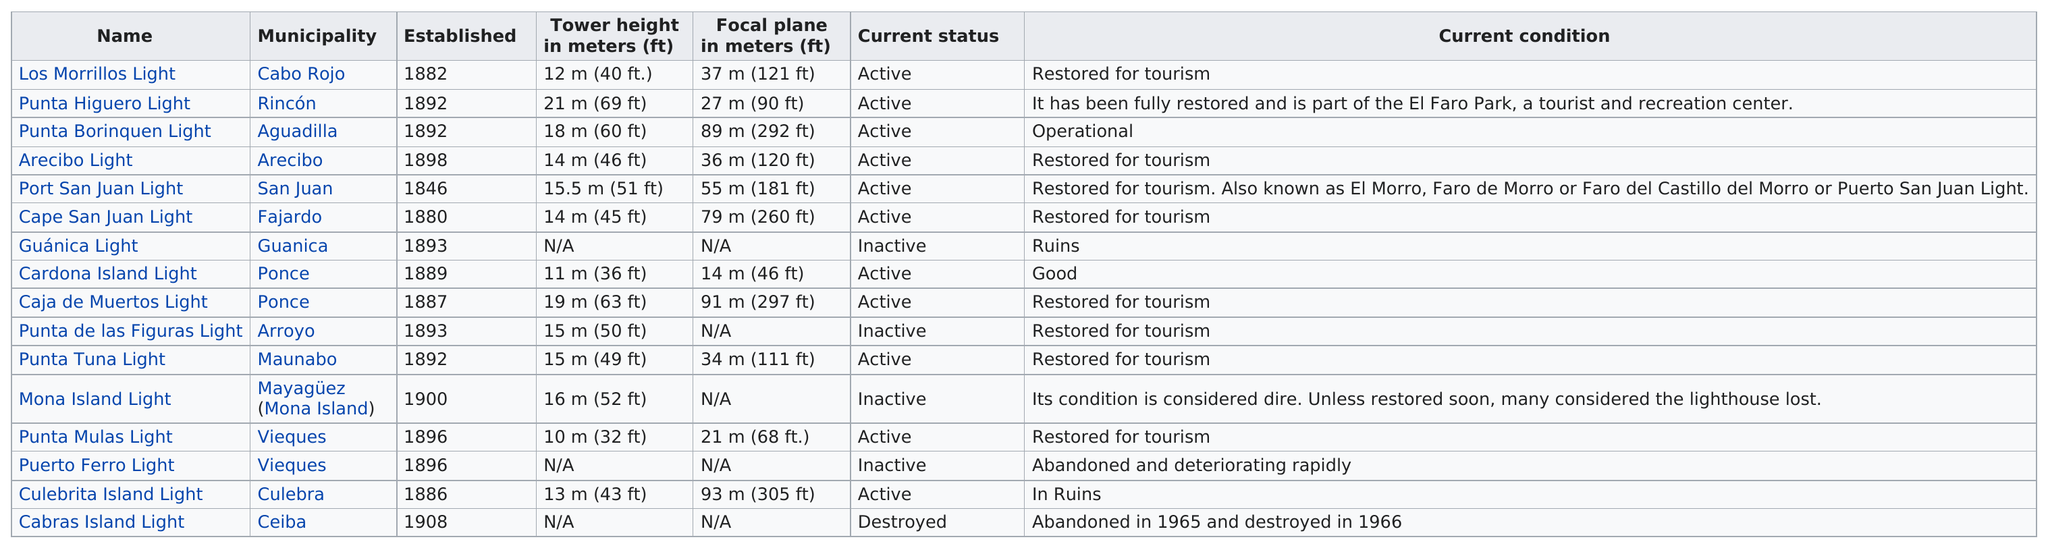Specify some key components in this picture. Cardona Island Light and Caja de Muertos Light are located within the jurisdiction of the municipality of Ponce. San Juan was the first municipality to be established. According to historical records, a total of 13 lighthouses were established prior to 1898. Prior to 1880, several municipalities were established, including San Juan. According to the information provided, it can be concluded that at least one player achieved a tower height of 15.5 meters while playing the game "Port San Juan Light. 